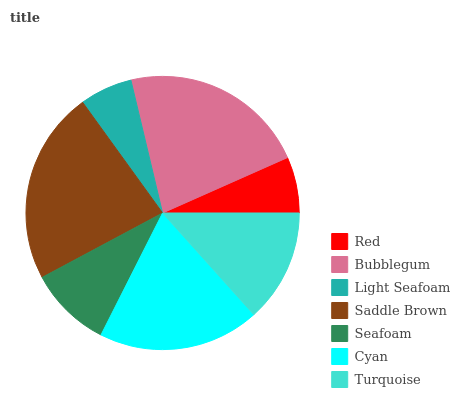Is Light Seafoam the minimum?
Answer yes or no. Yes. Is Saddle Brown the maximum?
Answer yes or no. Yes. Is Bubblegum the minimum?
Answer yes or no. No. Is Bubblegum the maximum?
Answer yes or no. No. Is Bubblegum greater than Red?
Answer yes or no. Yes. Is Red less than Bubblegum?
Answer yes or no. Yes. Is Red greater than Bubblegum?
Answer yes or no. No. Is Bubblegum less than Red?
Answer yes or no. No. Is Turquoise the high median?
Answer yes or no. Yes. Is Turquoise the low median?
Answer yes or no. Yes. Is Red the high median?
Answer yes or no. No. Is Light Seafoam the low median?
Answer yes or no. No. 